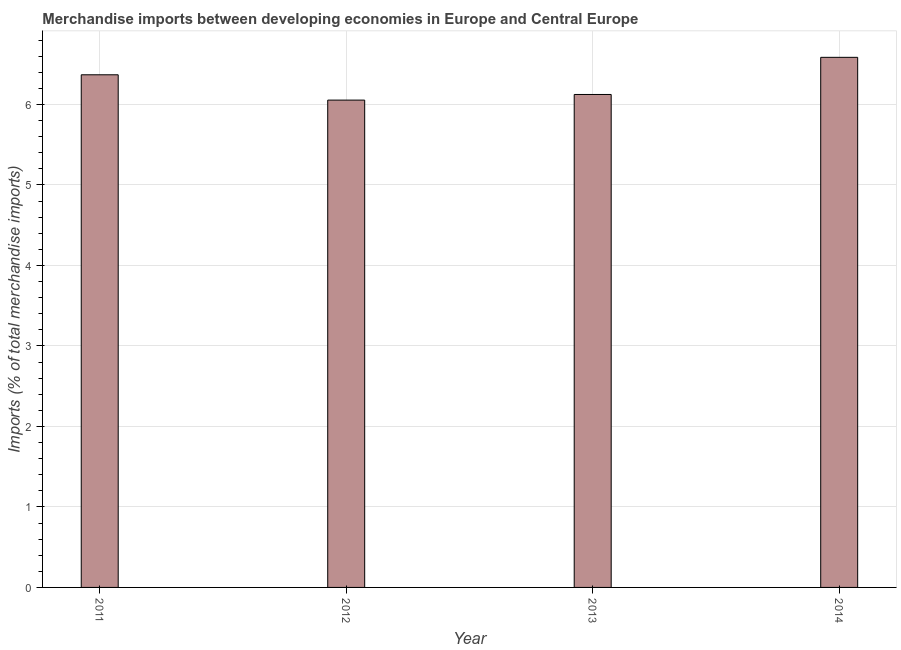Does the graph contain any zero values?
Make the answer very short. No. What is the title of the graph?
Ensure brevity in your answer.  Merchandise imports between developing economies in Europe and Central Europe. What is the label or title of the Y-axis?
Offer a very short reply. Imports (% of total merchandise imports). What is the merchandise imports in 2012?
Your answer should be very brief. 6.05. Across all years, what is the maximum merchandise imports?
Offer a very short reply. 6.59. Across all years, what is the minimum merchandise imports?
Give a very brief answer. 6.05. In which year was the merchandise imports maximum?
Keep it short and to the point. 2014. What is the sum of the merchandise imports?
Ensure brevity in your answer.  25.13. What is the difference between the merchandise imports in 2011 and 2013?
Offer a terse response. 0.24. What is the average merchandise imports per year?
Your answer should be compact. 6.28. What is the median merchandise imports?
Offer a terse response. 6.25. What is the ratio of the merchandise imports in 2013 to that in 2014?
Ensure brevity in your answer.  0.93. Is the merchandise imports in 2013 less than that in 2014?
Make the answer very short. Yes. Is the difference between the merchandise imports in 2011 and 2012 greater than the difference between any two years?
Your answer should be compact. No. What is the difference between the highest and the second highest merchandise imports?
Provide a succinct answer. 0.22. What is the difference between the highest and the lowest merchandise imports?
Offer a terse response. 0.53. In how many years, is the merchandise imports greater than the average merchandise imports taken over all years?
Provide a short and direct response. 2. How many bars are there?
Offer a terse response. 4. Are all the bars in the graph horizontal?
Your answer should be compact. No. How many years are there in the graph?
Ensure brevity in your answer.  4. What is the difference between two consecutive major ticks on the Y-axis?
Give a very brief answer. 1. Are the values on the major ticks of Y-axis written in scientific E-notation?
Give a very brief answer. No. What is the Imports (% of total merchandise imports) of 2011?
Provide a short and direct response. 6.37. What is the Imports (% of total merchandise imports) in 2012?
Offer a terse response. 6.05. What is the Imports (% of total merchandise imports) of 2013?
Your answer should be compact. 6.12. What is the Imports (% of total merchandise imports) in 2014?
Your response must be concise. 6.59. What is the difference between the Imports (% of total merchandise imports) in 2011 and 2012?
Offer a very short reply. 0.31. What is the difference between the Imports (% of total merchandise imports) in 2011 and 2013?
Offer a terse response. 0.24. What is the difference between the Imports (% of total merchandise imports) in 2011 and 2014?
Give a very brief answer. -0.22. What is the difference between the Imports (% of total merchandise imports) in 2012 and 2013?
Offer a very short reply. -0.07. What is the difference between the Imports (% of total merchandise imports) in 2012 and 2014?
Ensure brevity in your answer.  -0.53. What is the difference between the Imports (% of total merchandise imports) in 2013 and 2014?
Provide a short and direct response. -0.46. What is the ratio of the Imports (% of total merchandise imports) in 2011 to that in 2012?
Keep it short and to the point. 1.05. What is the ratio of the Imports (% of total merchandise imports) in 2011 to that in 2013?
Ensure brevity in your answer.  1.04. What is the ratio of the Imports (% of total merchandise imports) in 2011 to that in 2014?
Your response must be concise. 0.97. What is the ratio of the Imports (% of total merchandise imports) in 2012 to that in 2013?
Keep it short and to the point. 0.99. What is the ratio of the Imports (% of total merchandise imports) in 2012 to that in 2014?
Offer a very short reply. 0.92. What is the ratio of the Imports (% of total merchandise imports) in 2013 to that in 2014?
Your response must be concise. 0.93. 